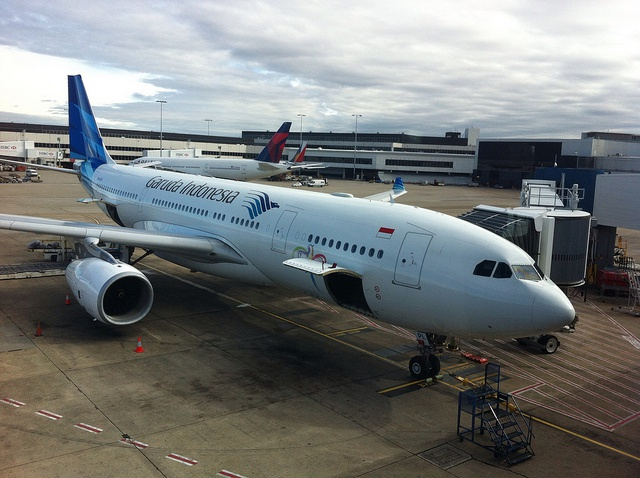Describe the objects in this image and their specific colors. I can see airplane in darkgray, gray, black, and lightgray tones, airplane in darkgray, gray, and black tones, car in darkgray, gray, black, and white tones, and car in darkgray, gray, and lightgray tones in this image. 